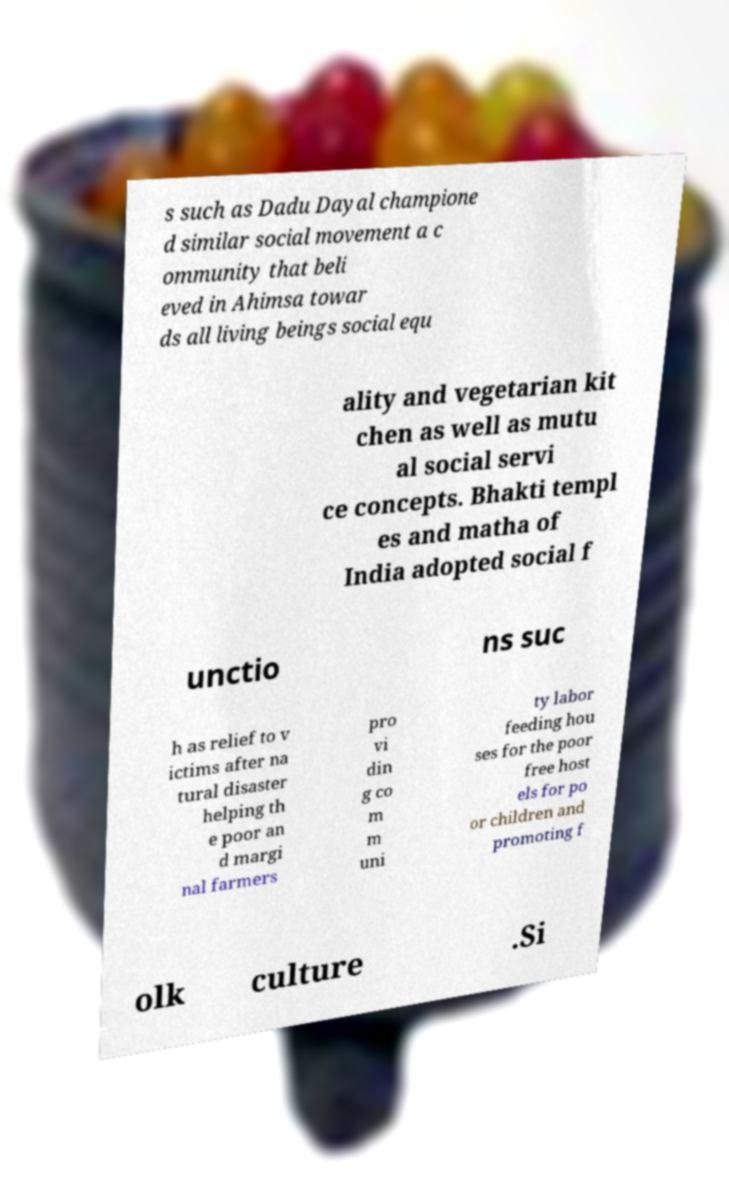Could you assist in decoding the text presented in this image and type it out clearly? s such as Dadu Dayal champione d similar social movement a c ommunity that beli eved in Ahimsa towar ds all living beings social equ ality and vegetarian kit chen as well as mutu al social servi ce concepts. Bhakti templ es and matha of India adopted social f unctio ns suc h as relief to v ictims after na tural disaster helping th e poor an d margi nal farmers pro vi din g co m m uni ty labor feeding hou ses for the poor free host els for po or children and promoting f olk culture .Si 